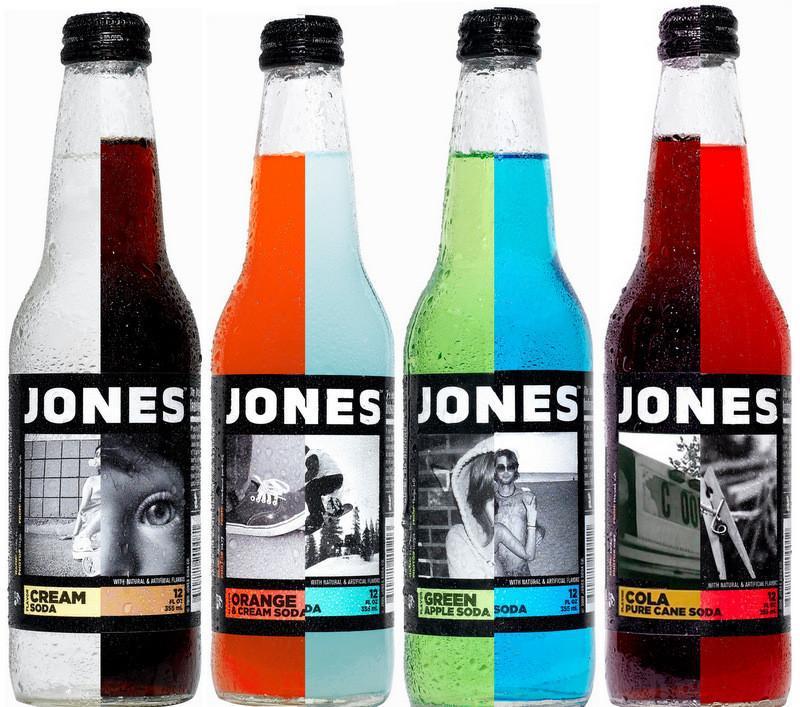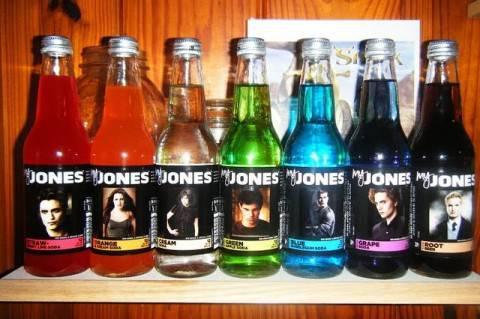The first image is the image on the left, the second image is the image on the right. For the images shown, is this caption "There are seven bottles in total." true? Answer yes or no. No. The first image is the image on the left, the second image is the image on the right. Examine the images to the left and right. Is the description "There are exactly seven bottles in total." accurate? Answer yes or no. No. 